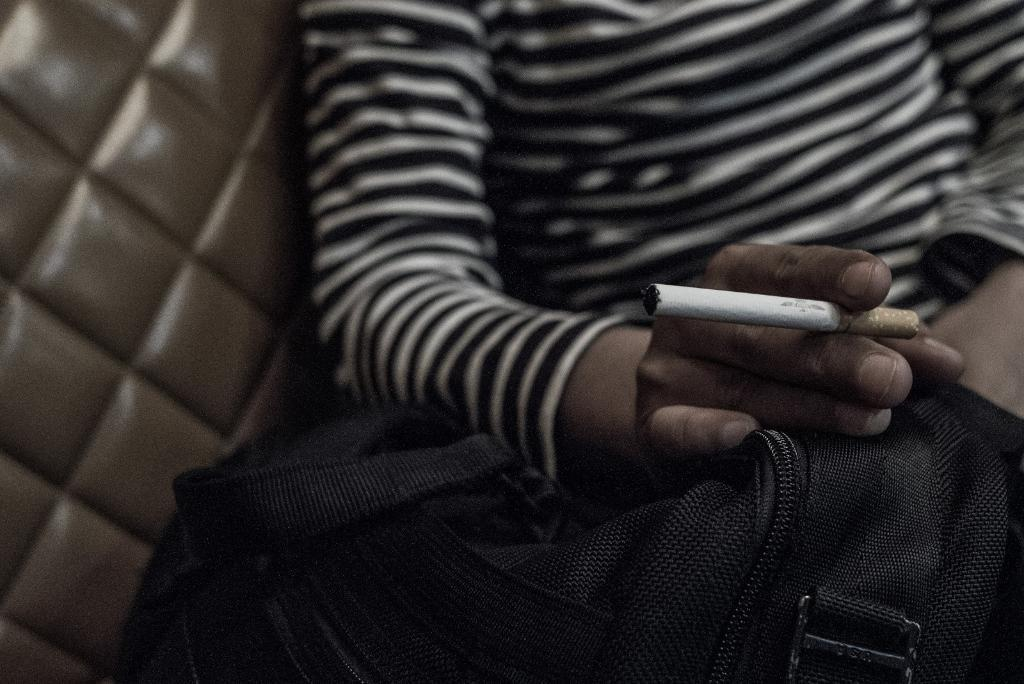What can be seen in the image related to a person? There is a person in the image. What is the person wearing? The person is wearing a black and white T-shirt. What is the person holding in the image? The person is holding a cigarette. What type of bag is present in the image? There is a black color bag in the image. Can you describe any visual effect in the image? A part of the image is blurred. What is the price of the caption on the person's T-shirt? There is no caption or price mentioned on the person's T-shirt; it is simply described as a black and white T-shirt. 